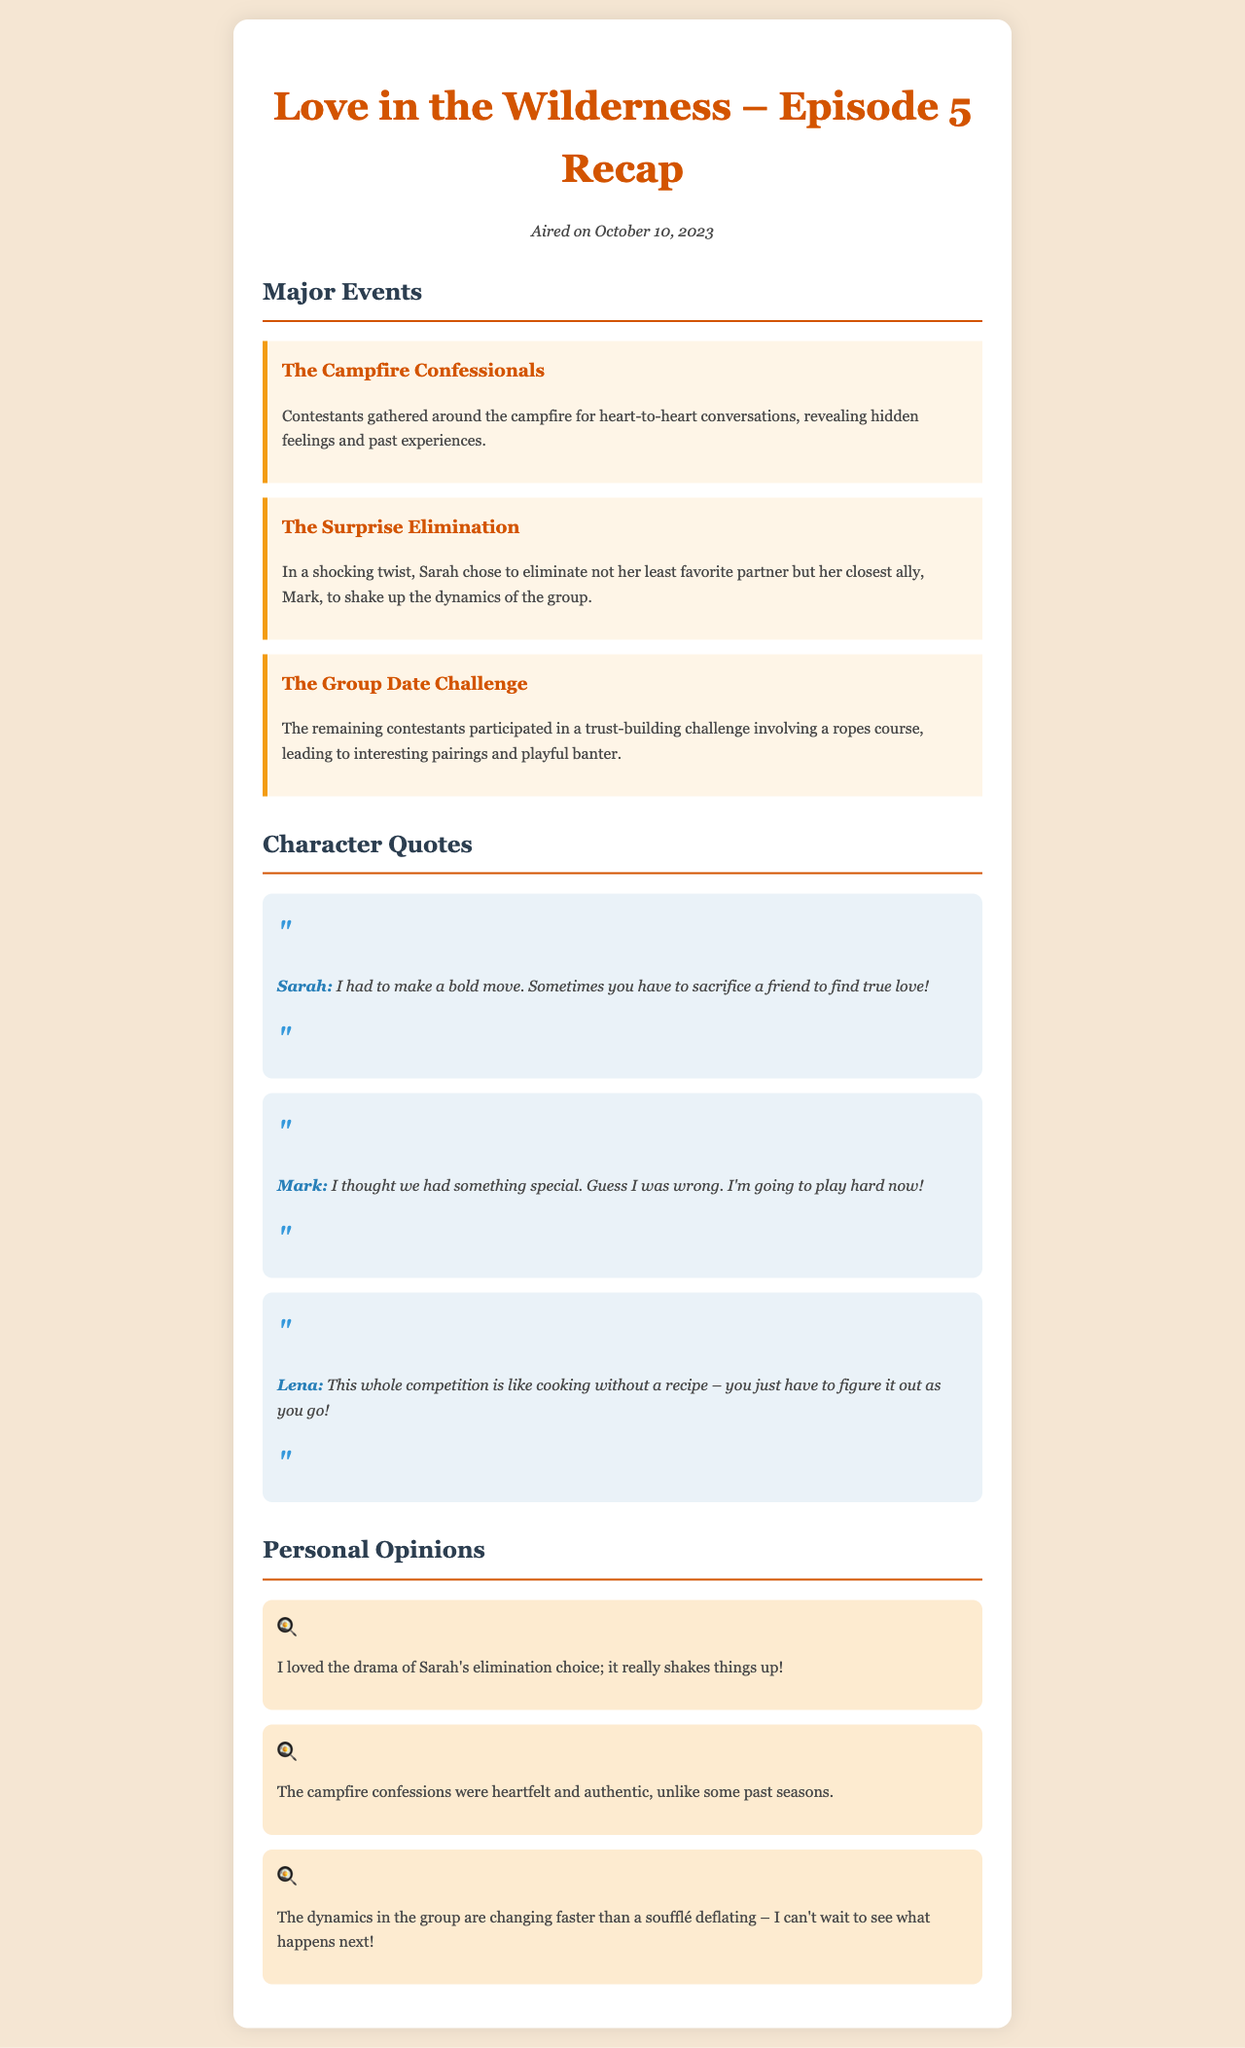what is the title of the episode? The title of the episode is stated in the document heading.
Answer: Love in the Wilderness – Episode 5 Recap when did the episode air? The air date is clearly noted in the document.
Answer: October 10, 2023 who did Sarah eliminate? The elimination details specify that Sarah chose to eliminate Mark.
Answer: Mark what challenge did the contestants participate in? The type of challenge is mentioned in the summary of major events.
Answer: Trust-building challenge what did Sarah say about her bold move? Sarah's quote reflects her perspective on her decision.
Answer: I had to make a bold move. Sometimes you have to sacrifice a friend to find true love! how did Mark react to his elimination? Mark's quote reveals his feelings about the situation.
Answer: I thought we had something special. Guess I was wrong. I'm going to play hard now! which character compared the competition to cooking? Lena's quote compares the competition to cooking without a recipe.
Answer: Lena what was the personal opinion about Sarah's elimination choice? One of the personal opinions expressed a strong reaction to Sarah's choice.
Answer: it really shakes things up! 